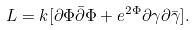<formula> <loc_0><loc_0><loc_500><loc_500>L = k [ { \partial { \Phi } } { \bar { \partial } } { \Phi } + e ^ { 2 { \Phi } } { \partial { \gamma } } { \partial { \bar { \gamma } } } ] .</formula> 